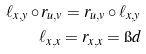<formula> <loc_0><loc_0><loc_500><loc_500>\ell _ { x , y } \circ r _ { u , v } = r _ { u , v } \circ \ell _ { x , y } \\ \ell _ { x , x } = r _ { x , x } = \i d</formula> 